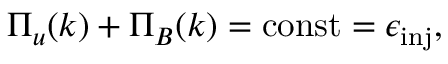<formula> <loc_0><loc_0><loc_500><loc_500>\Pi _ { u } ( k ) + \Pi _ { B } ( k ) = c o n s t = \epsilon _ { i n j } ,</formula> 